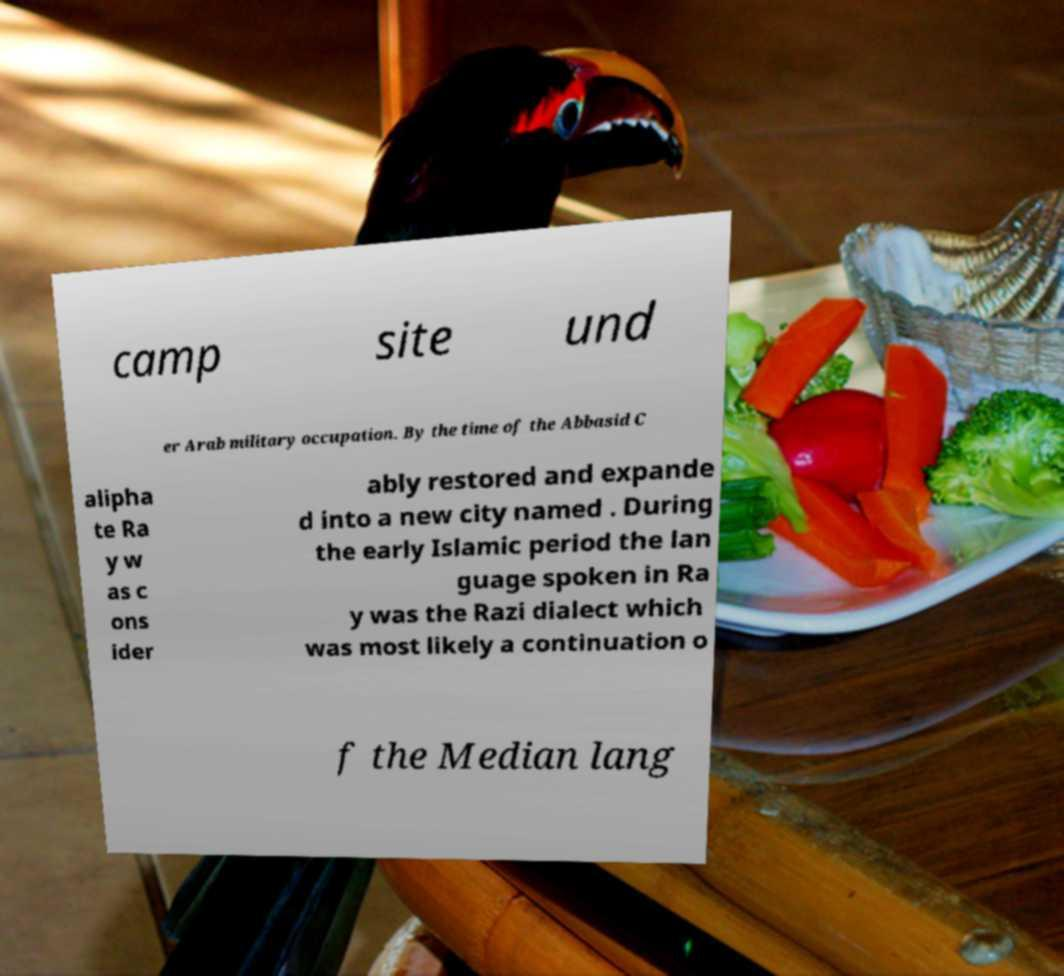Can you read and provide the text displayed in the image?This photo seems to have some interesting text. Can you extract and type it out for me? camp site und er Arab military occupation. By the time of the Abbasid C alipha te Ra y w as c ons ider ably restored and expande d into a new city named . During the early Islamic period the lan guage spoken in Ra y was the Razi dialect which was most likely a continuation o f the Median lang 